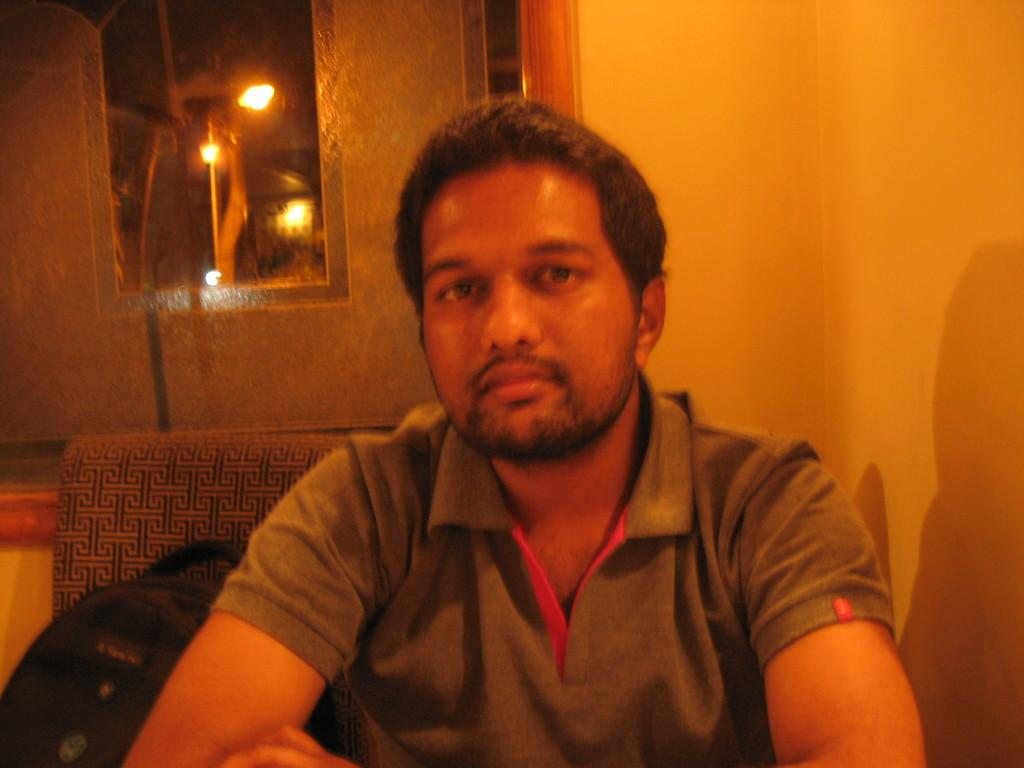Who is present in the image? There is a man in the image. What is the man doing in the image? The man is seated. What object is beside the man? There is a bag beside the man. What can be seen in the background of the image? There are lights visible in the background of the image. What type of lipstick is the man wearing in the image? The man is not wearing lipstick in the image, as he is a male and lipstick is typically worn by females. 